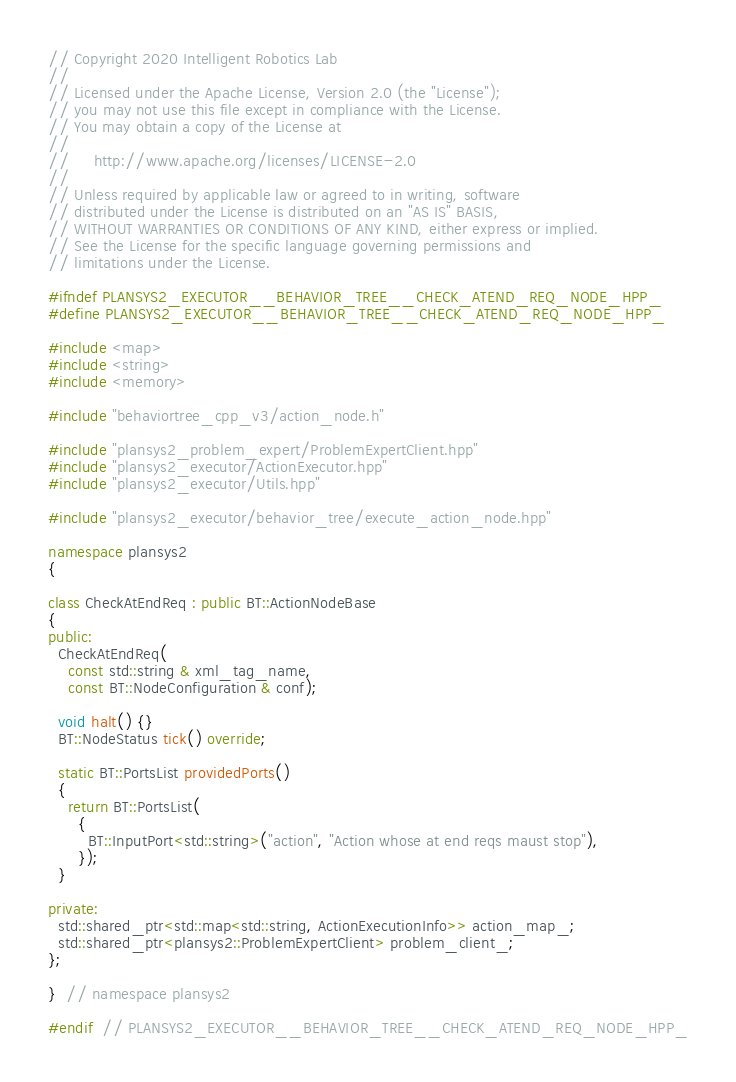Convert code to text. <code><loc_0><loc_0><loc_500><loc_500><_C++_>// Copyright 2020 Intelligent Robotics Lab
//
// Licensed under the Apache License, Version 2.0 (the "License");
// you may not use this file except in compliance with the License.
// You may obtain a copy of the License at
//
//     http://www.apache.org/licenses/LICENSE-2.0
//
// Unless required by applicable law or agreed to in writing, software
// distributed under the License is distributed on an "AS IS" BASIS,
// WITHOUT WARRANTIES OR CONDITIONS OF ANY KIND, either express or implied.
// See the License for the specific language governing permissions and
// limitations under the License.

#ifndef PLANSYS2_EXECUTOR__BEHAVIOR_TREE__CHECK_ATEND_REQ_NODE_HPP_
#define PLANSYS2_EXECUTOR__BEHAVIOR_TREE__CHECK_ATEND_REQ_NODE_HPP_

#include <map>
#include <string>
#include <memory>

#include "behaviortree_cpp_v3/action_node.h"

#include "plansys2_problem_expert/ProblemExpertClient.hpp"
#include "plansys2_executor/ActionExecutor.hpp"
#include "plansys2_executor/Utils.hpp"

#include "plansys2_executor/behavior_tree/execute_action_node.hpp"

namespace plansys2
{

class CheckAtEndReq : public BT::ActionNodeBase
{
public:
  CheckAtEndReq(
    const std::string & xml_tag_name,
    const BT::NodeConfiguration & conf);

  void halt() {}
  BT::NodeStatus tick() override;

  static BT::PortsList providedPorts()
  {
    return BT::PortsList(
      {
        BT::InputPort<std::string>("action", "Action whose at end reqs maust stop"),
      });
  }

private:
  std::shared_ptr<std::map<std::string, ActionExecutionInfo>> action_map_;
  std::shared_ptr<plansys2::ProblemExpertClient> problem_client_;
};

}  // namespace plansys2

#endif  // PLANSYS2_EXECUTOR__BEHAVIOR_TREE__CHECK_ATEND_REQ_NODE_HPP_
</code> 